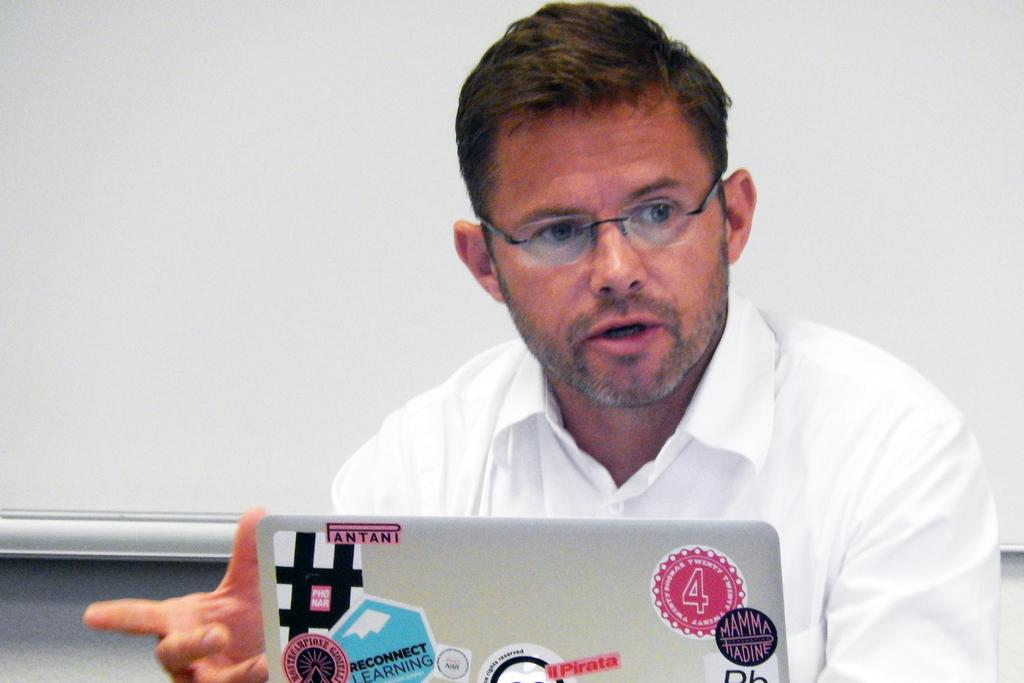Who or what is the main subject in the image? There is a person in the image. What is the person doing in the image? The person is sitting on a chair. What object is in front of the person? There is a laptop in front of the person. What type of ornament is the person holding in the image? There is no ornament present in the image; the person is sitting with a laptop in front of them. 